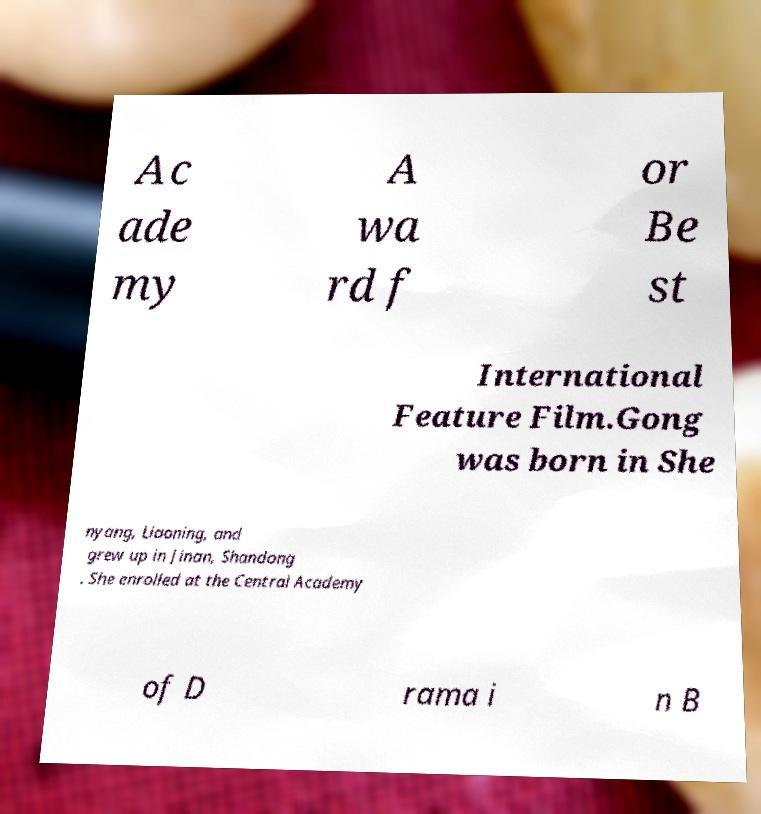For documentation purposes, I need the text within this image transcribed. Could you provide that? Ac ade my A wa rd f or Be st International Feature Film.Gong was born in She nyang, Liaoning, and grew up in Jinan, Shandong . She enrolled at the Central Academy of D rama i n B 